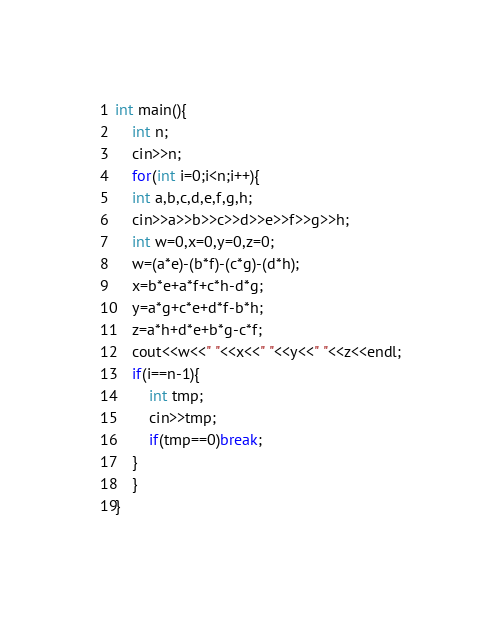Convert code to text. <code><loc_0><loc_0><loc_500><loc_500><_C++_>int main(){
	int n;
	cin>>n;
	for(int i=0;i<n;i++){
	int a,b,c,d,e,f,g,h;
	cin>>a>>b>>c>>d>>e>>f>>g>>h;
	int w=0,x=0,y=0,z=0;
	w=(a*e)-(b*f)-(c*g)-(d*h);
	x=b*e+a*f+c*h-d*g;
	y=a*g+c*e+d*f-b*h;
	z=a*h+d*e+b*g-c*f;
	cout<<w<<" "<<x<<" "<<y<<" "<<z<<endl;
	if(i==n-1){
		int tmp;
		cin>>tmp;
		if(tmp==0)break;
	}
	}
}</code> 